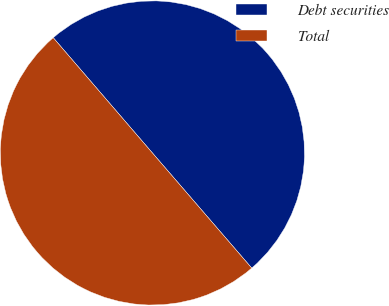Convert chart. <chart><loc_0><loc_0><loc_500><loc_500><pie_chart><fcel>Debt securities<fcel>Total<nl><fcel>49.98%<fcel>50.02%<nl></chart> 